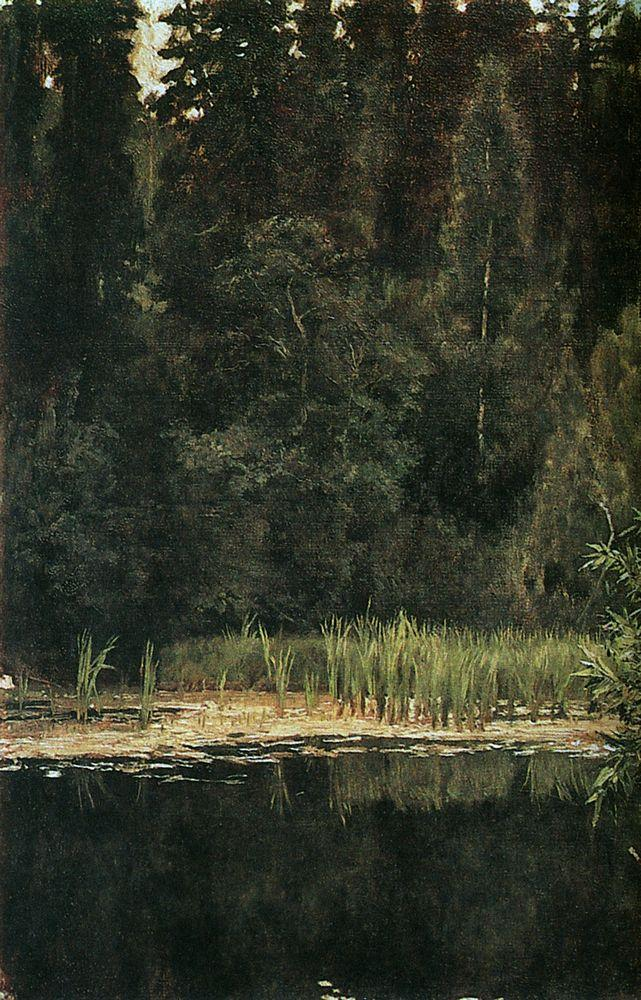Can you tell me about the artistic techniques used in this painting? Certainly, the artist employs a realistic approach with a romantic twist, paying close attention to the way natural light diffuses through the canopy. The brushstrokes here are delicate and detailed, capturing the texture of leaves and the bark on trees, as well as the smooth, reflective surface of the pond. There is also a subtle interplay between light and shadow, which creates depth and volume without the use of harsh lines. This technique may suggest influence from the Barbizon school, which focused on realistic representations of nature and atmosphere. 